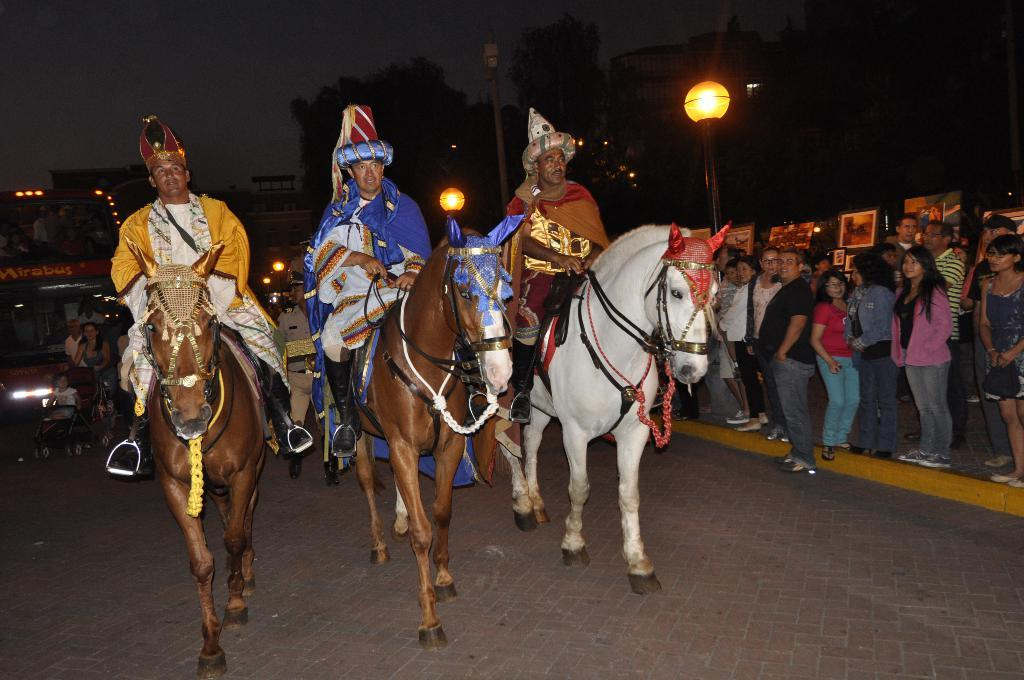How many persons are riding horses in the image? There are three persons sitting on horses in the image. What can be seen in the background of the image? In the background, there is a group of people standing, boards, lights, poles, a vehicle, buildings, trees, and the sky. What might be the purpose of the boards visible in the background? The purpose of the boards is not explicitly stated in the image, but they could be part of a fence, signage, or a structure. Can you tell me how many geese are shaking their sweaters in the image? There are no geese or sweaters present in the image. What type of sweater is the person on the left wearing in the image? There is no person wearing a sweater in the image; the three persons are riding horses. 